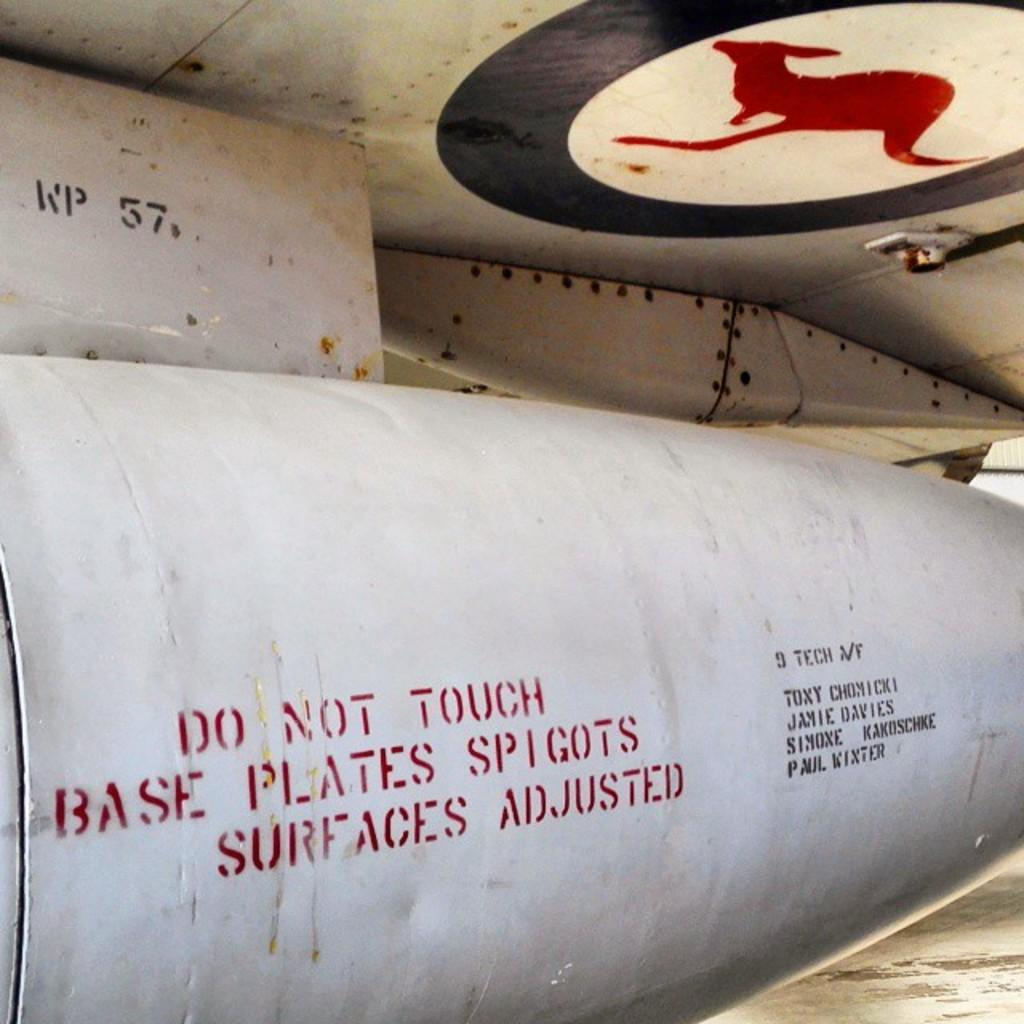<image>
Render a clear and concise summary of the photo. The underside of an airplane has the picture of a kangaroo and says "Do Not Touch". 